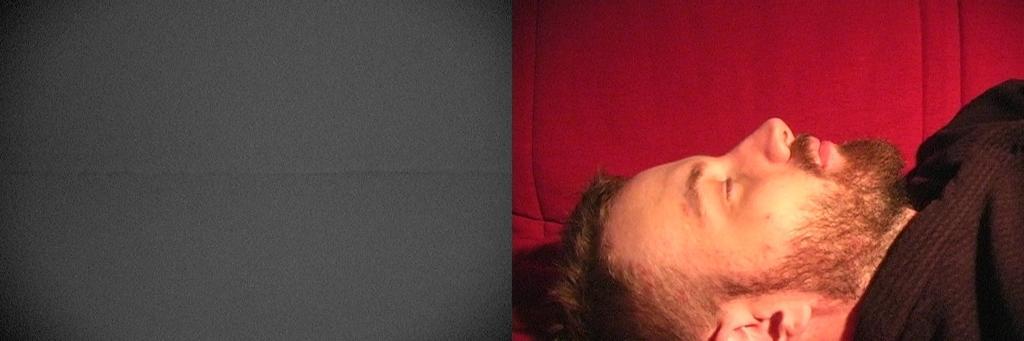Please provide a concise description of this image. On the right side of the image we can see a person sleeping. 